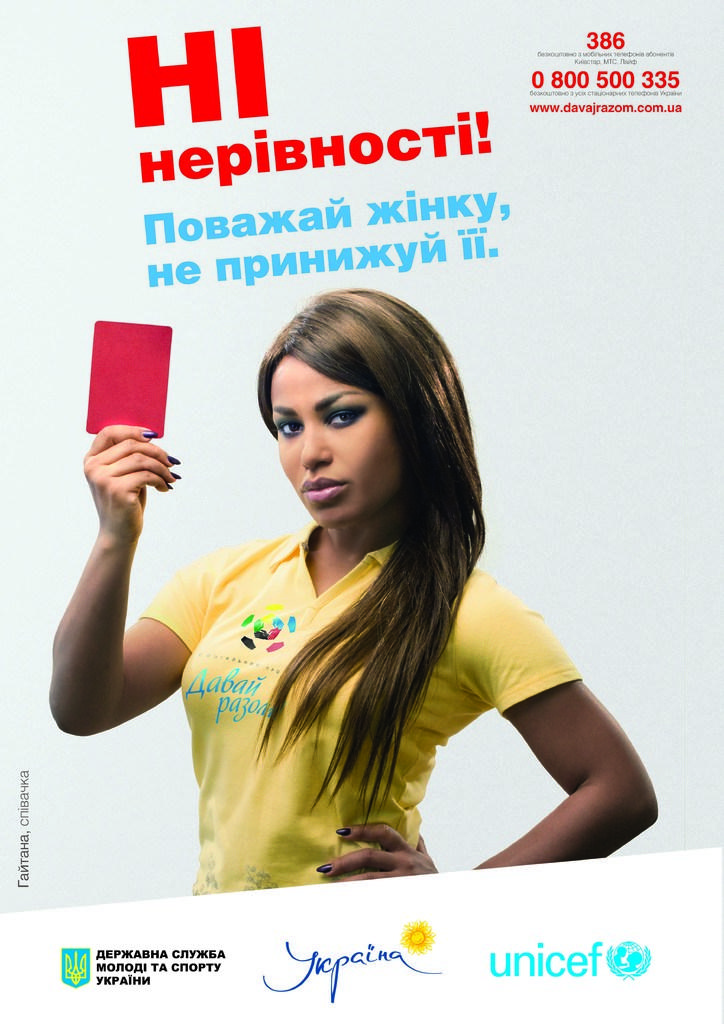Who is the main subject in the image? There is a lady in the image. What is the lady wearing? The lady is wearing a yellow t-shirt. What is the lady holding in the image? The lady is holding a red card. What can be seen at the top of the image? There is text written at the top of the image. What is present at the bottom of the image? There are logos and text at the bottom of the image. What type of mist can be seen surrounding the lady in the image? There is no mist present in the image; it is a clear scene. What kind of party is the lady attending in the image? There is no indication of a party in the image; it only shows the lady holding a red card. 